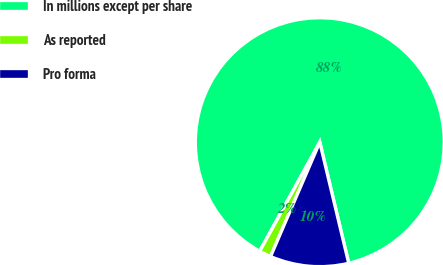Convert chart to OTSL. <chart><loc_0><loc_0><loc_500><loc_500><pie_chart><fcel>In millions except per share<fcel>As reported<fcel>Pro forma<nl><fcel>88.25%<fcel>1.54%<fcel>10.21%<nl></chart> 